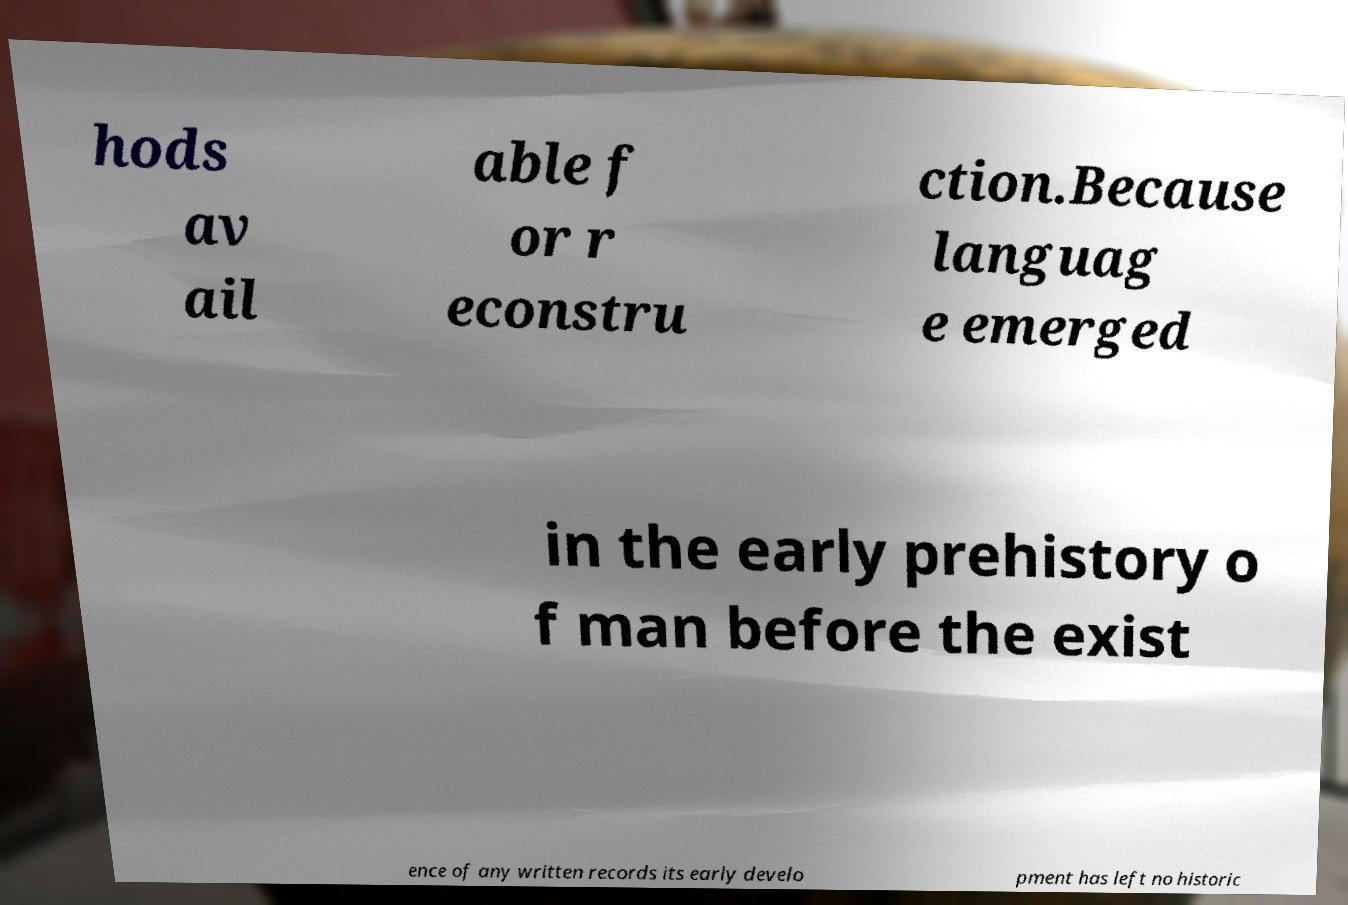What messages or text are displayed in this image? I need them in a readable, typed format. hods av ail able f or r econstru ction.Because languag e emerged in the early prehistory o f man before the exist ence of any written records its early develo pment has left no historic 